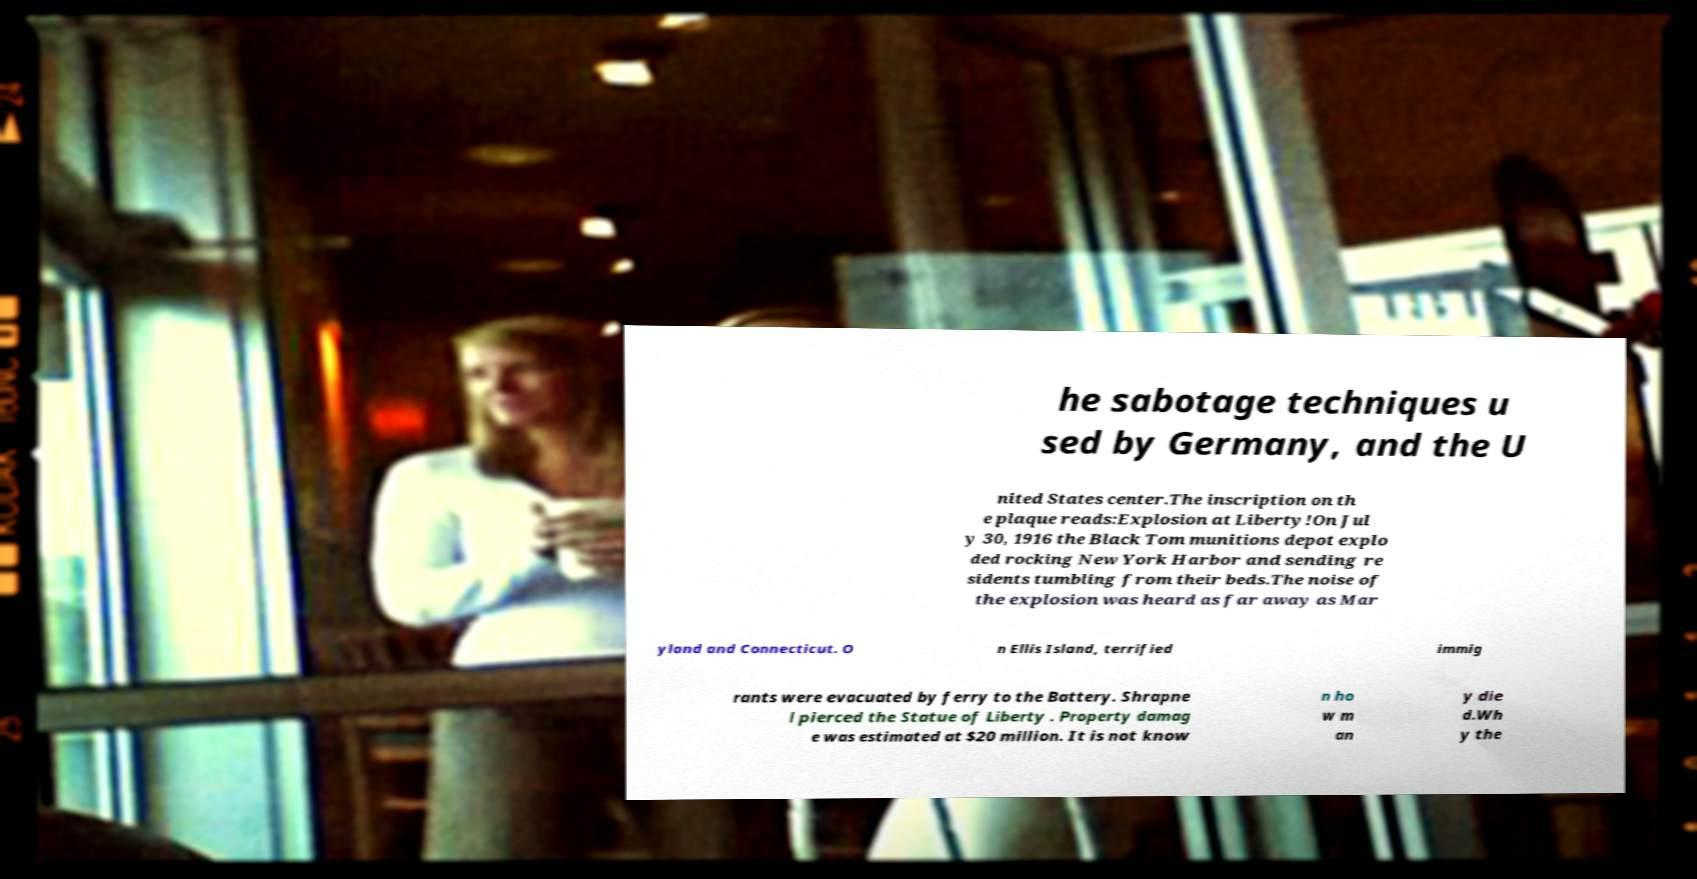What messages or text are displayed in this image? I need them in a readable, typed format. he sabotage techniques u sed by Germany, and the U nited States center.The inscription on th e plaque reads:Explosion at Liberty!On Jul y 30, 1916 the Black Tom munitions depot explo ded rocking New York Harbor and sending re sidents tumbling from their beds.The noise of the explosion was heard as far away as Mar yland and Connecticut. O n Ellis Island, terrified immig rants were evacuated by ferry to the Battery. Shrapne l pierced the Statue of Liberty . Property damag e was estimated at $20 million. It is not know n ho w m an y die d.Wh y the 